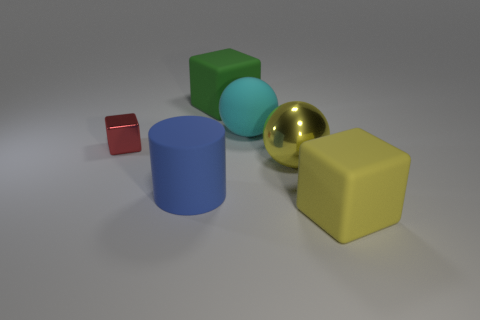Subtract all gray cylinders. Subtract all green cubes. How many cylinders are left? 1 Add 4 small red shiny objects. How many objects exist? 10 Subtract all cylinders. How many objects are left? 5 Subtract 0 green spheres. How many objects are left? 6 Subtract all large blue rubber objects. Subtract all green matte cubes. How many objects are left? 4 Add 1 red things. How many red things are left? 2 Add 3 large blue cylinders. How many large blue cylinders exist? 4 